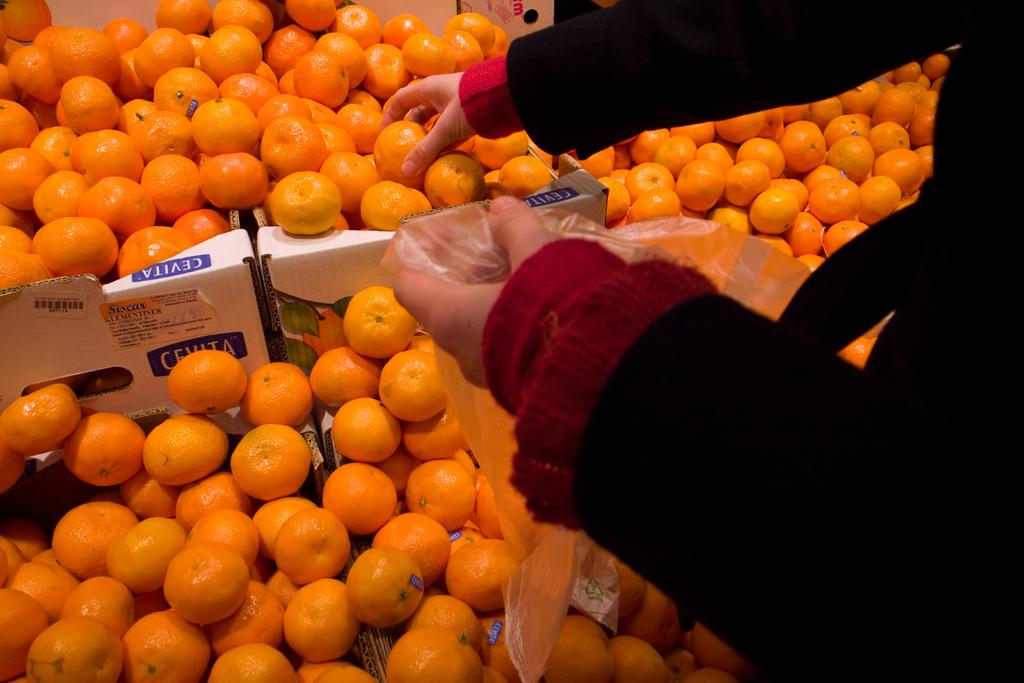What type of food is visible in the image? There are fruits in the image. Can you describe the person in the image? There is a person standing on the right side of the image. What type of thought can be seen in the image? There is no thought visible in the image; it features fruits and a person. What type of horse is present in the image? There is no horse present in the image. 